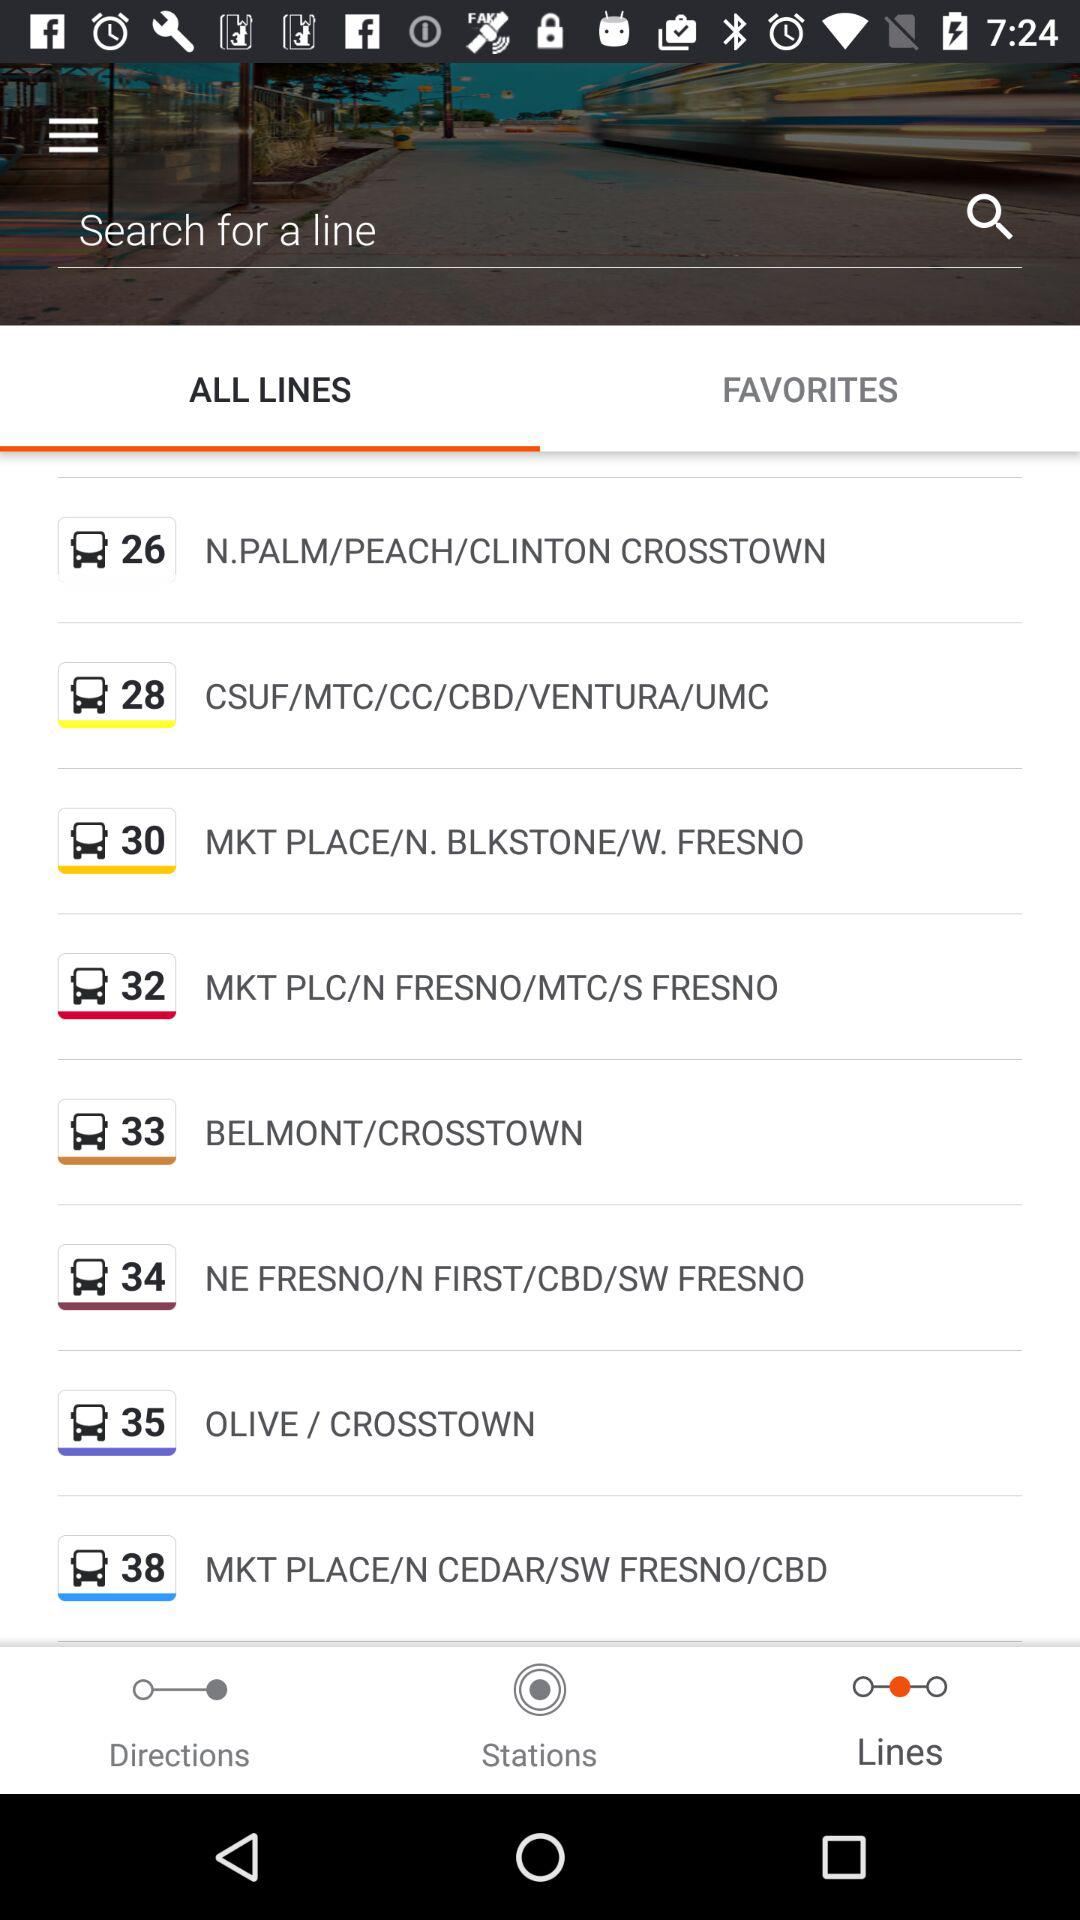Which tab is selected? The selected tab is "ALL LINES". 